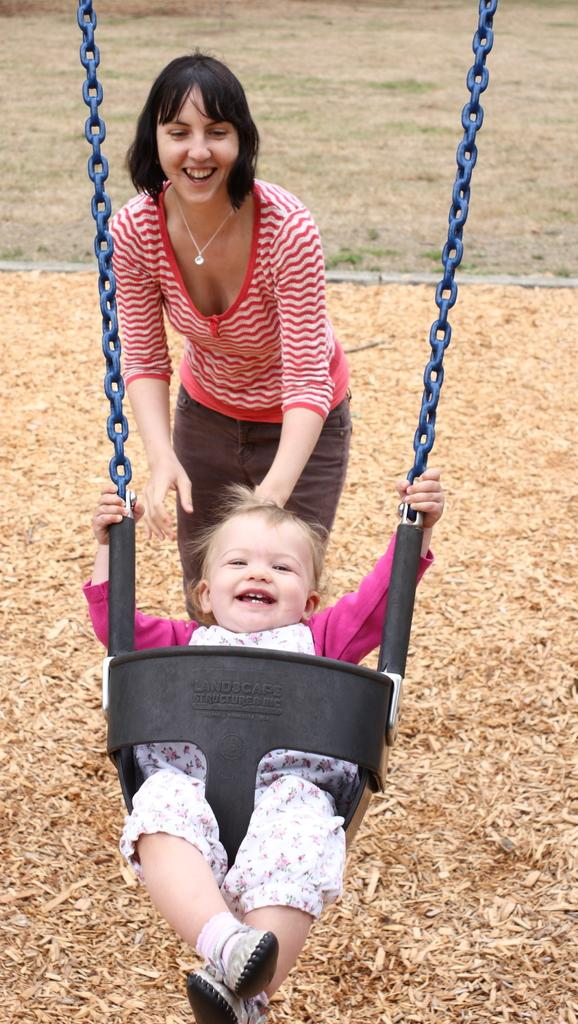Who is present in the image? There is a woman and a small kid in the image. What is the kid doing in the image? The kid is sitting in a swing and swinging. What can be seen on the ground in the image? Dried leaves are present on the ground. How does the wealth of the woman in the image affect the kid's mind? There is no information about the woman's wealth or the kid's mind in the image, so it cannot be determined. How many brothers does the kid have in the image? There is no information about the kid's brothers in the image, so it cannot be determined. 